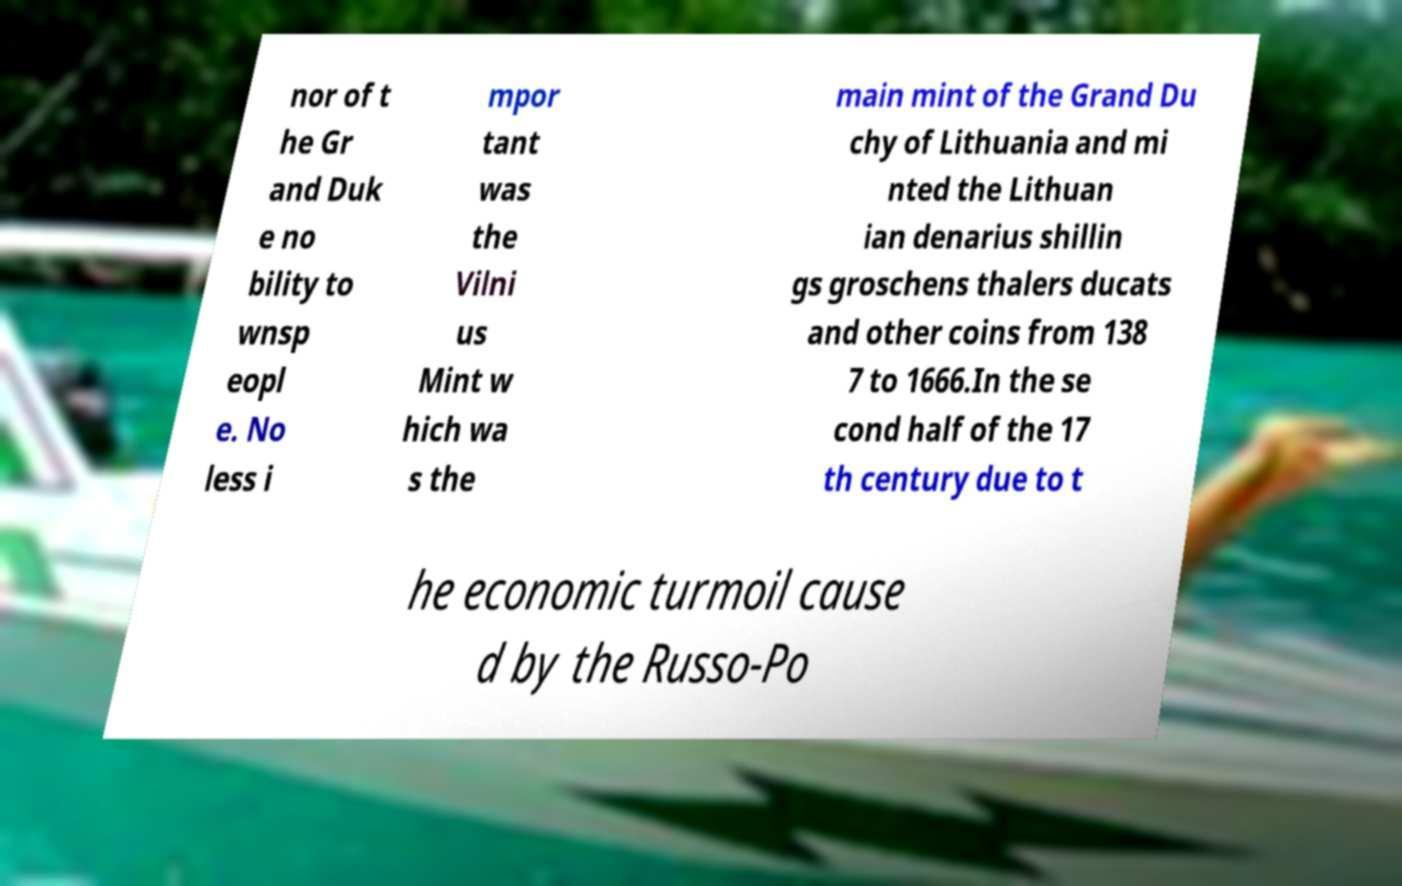What messages or text are displayed in this image? I need them in a readable, typed format. nor of t he Gr and Duk e no bility to wnsp eopl e. No less i mpor tant was the Vilni us Mint w hich wa s the main mint of the Grand Du chy of Lithuania and mi nted the Lithuan ian denarius shillin gs groschens thalers ducats and other coins from 138 7 to 1666.In the se cond half of the 17 th century due to t he economic turmoil cause d by the Russo-Po 